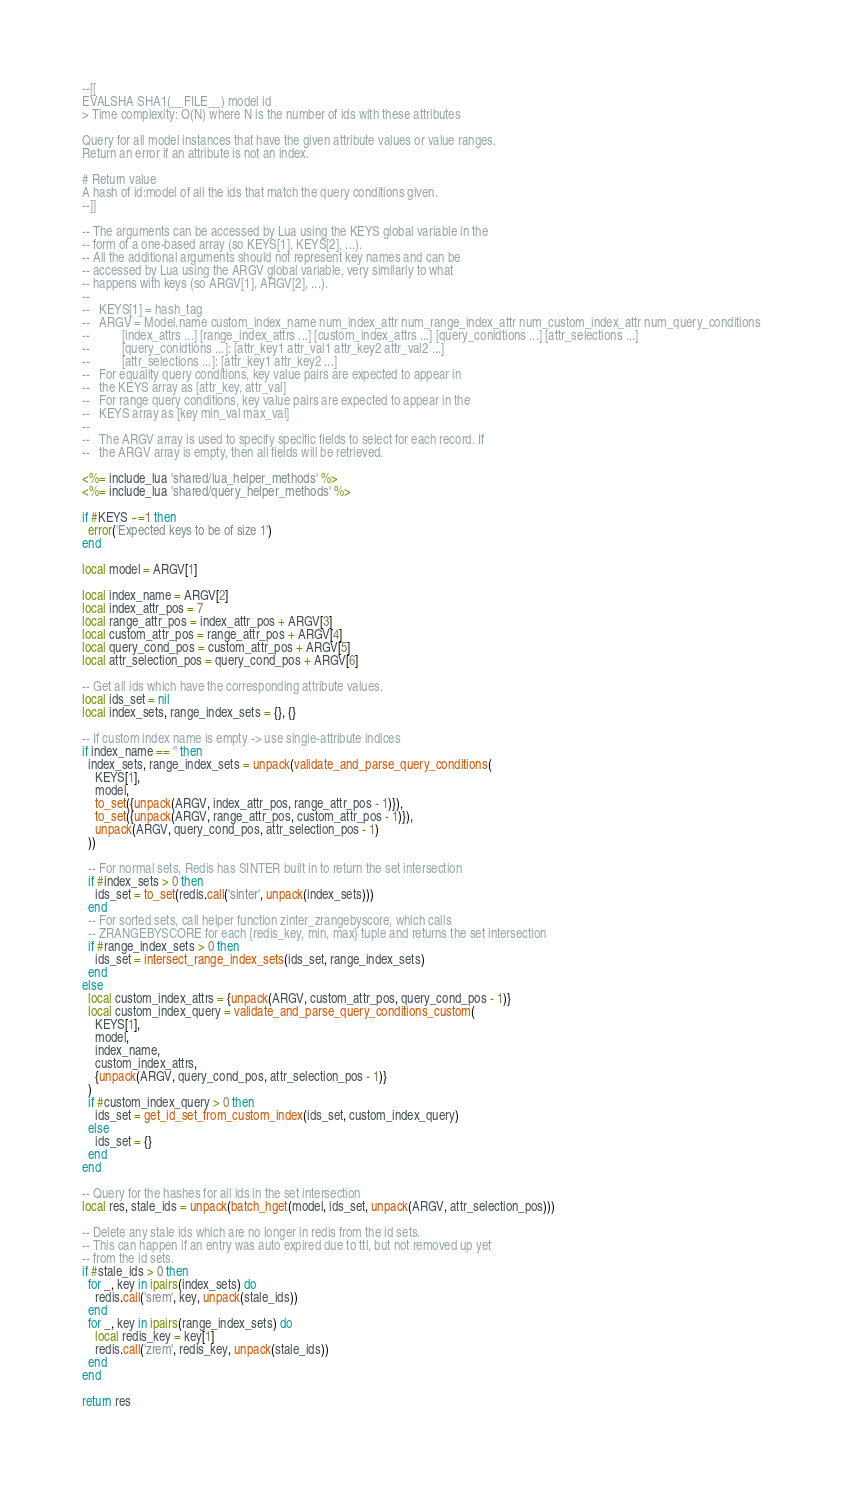Convert code to text. <code><loc_0><loc_0><loc_500><loc_500><_Lua_>--[[
EVALSHA SHA1(__FILE__) model id
> Time complexity: O(N) where N is the number of ids with these attributes

Query for all model instances that have the given attribute values or value ranges.
Return an error if an attribute is not an index.

# Return value
A hash of id:model of all the ids that match the query conditions given.
--]]

-- The arguments can be accessed by Lua using the KEYS global variable in the
-- form of a one-based array (so KEYS[1], KEYS[2], ...).
-- All the additional arguments should not represent key names and can be
-- accessed by Lua using the ARGV global variable, very similarly to what
-- happens with keys (so ARGV[1], ARGV[2], ...).
--
--   KEYS[1] = hash_tag
--   ARGV = Model.name custom_index_name num_index_attr num_range_index_attr num_custom_index_attr num_query_conditions 
--          [index_attrs ...] [range_index_attrs ...] [custom_index_attrs ...] [query_conidtions ...] [attr_selections ...]
--          [query_conidtions ...]: [attr_key1 attr_val1 attr_key2 attr_val2 ...]
--          [attr_selections ...]: [attr_key1 attr_key2 ...]
--   For equality query conditions, key value pairs are expected to appear in
--   the KEYS array as [attr_key, attr_val]
--   For range query conditions, key value pairs are expected to appear in the
--   KEYS array as [key min_val max_val]
--
--   The ARGV array is used to specify specific fields to select for each record. If
--   the ARGV array is empty, then all fields will be retrieved.

<%= include_lua 'shared/lua_helper_methods' %>
<%= include_lua 'shared/query_helper_methods' %>

if #KEYS ~=1 then
  error('Expected keys to be of size 1')
end

local model = ARGV[1]

local index_name = ARGV[2]
local index_attr_pos = 7
local range_attr_pos = index_attr_pos + ARGV[3]
local custom_attr_pos = range_attr_pos + ARGV[4]
local query_cond_pos = custom_attr_pos + ARGV[5]
local attr_selection_pos = query_cond_pos + ARGV[6]

-- Get all ids which have the corresponding attribute values.
local ids_set = nil
local index_sets, range_index_sets = {}, {}

-- If custom index name is empty -> use single-attribute indices
if index_name == '' then
  index_sets, range_index_sets = unpack(validate_and_parse_query_conditions(
    KEYS[1],
    model,
    to_set({unpack(ARGV, index_attr_pos, range_attr_pos - 1)}),
    to_set({unpack(ARGV, range_attr_pos, custom_attr_pos - 1)}),
    unpack(ARGV, query_cond_pos, attr_selection_pos - 1)
  ))

  -- For normal sets, Redis has SINTER built in to return the set intersection
  if #index_sets > 0 then
    ids_set = to_set(redis.call('sinter', unpack(index_sets)))
  end
  -- For sorted sets, call helper function zinter_zrangebyscore, which calls
  -- ZRANGEBYSCORE for each {redis_key, min, max} tuple and returns the set intersection
  if #range_index_sets > 0 then
    ids_set = intersect_range_index_sets(ids_set, range_index_sets)
  end
else
  local custom_index_attrs = {unpack(ARGV, custom_attr_pos, query_cond_pos - 1)}
  local custom_index_query = validate_and_parse_query_conditions_custom(
    KEYS[1],
    model,
    index_name,
    custom_index_attrs,
    {unpack(ARGV, query_cond_pos, attr_selection_pos - 1)}
  )
  if #custom_index_query > 0 then
    ids_set = get_id_set_from_custom_index(ids_set, custom_index_query)
  else
    ids_set = {}
  end
end

-- Query for the hashes for all ids in the set intersection
local res, stale_ids = unpack(batch_hget(model, ids_set, unpack(ARGV, attr_selection_pos)))

-- Delete any stale ids which are no longer in redis from the id sets.
-- This can happen if an entry was auto expired due to ttl, but not removed up yet
-- from the id sets.
if #stale_ids > 0 then
  for _, key in ipairs(index_sets) do
    redis.call('srem', key, unpack(stale_ids))
  end
  for _, key in ipairs(range_index_sets) do
    local redis_key = key[1]
    redis.call('zrem', redis_key, unpack(stale_ids))
  end
end

return res
</code> 